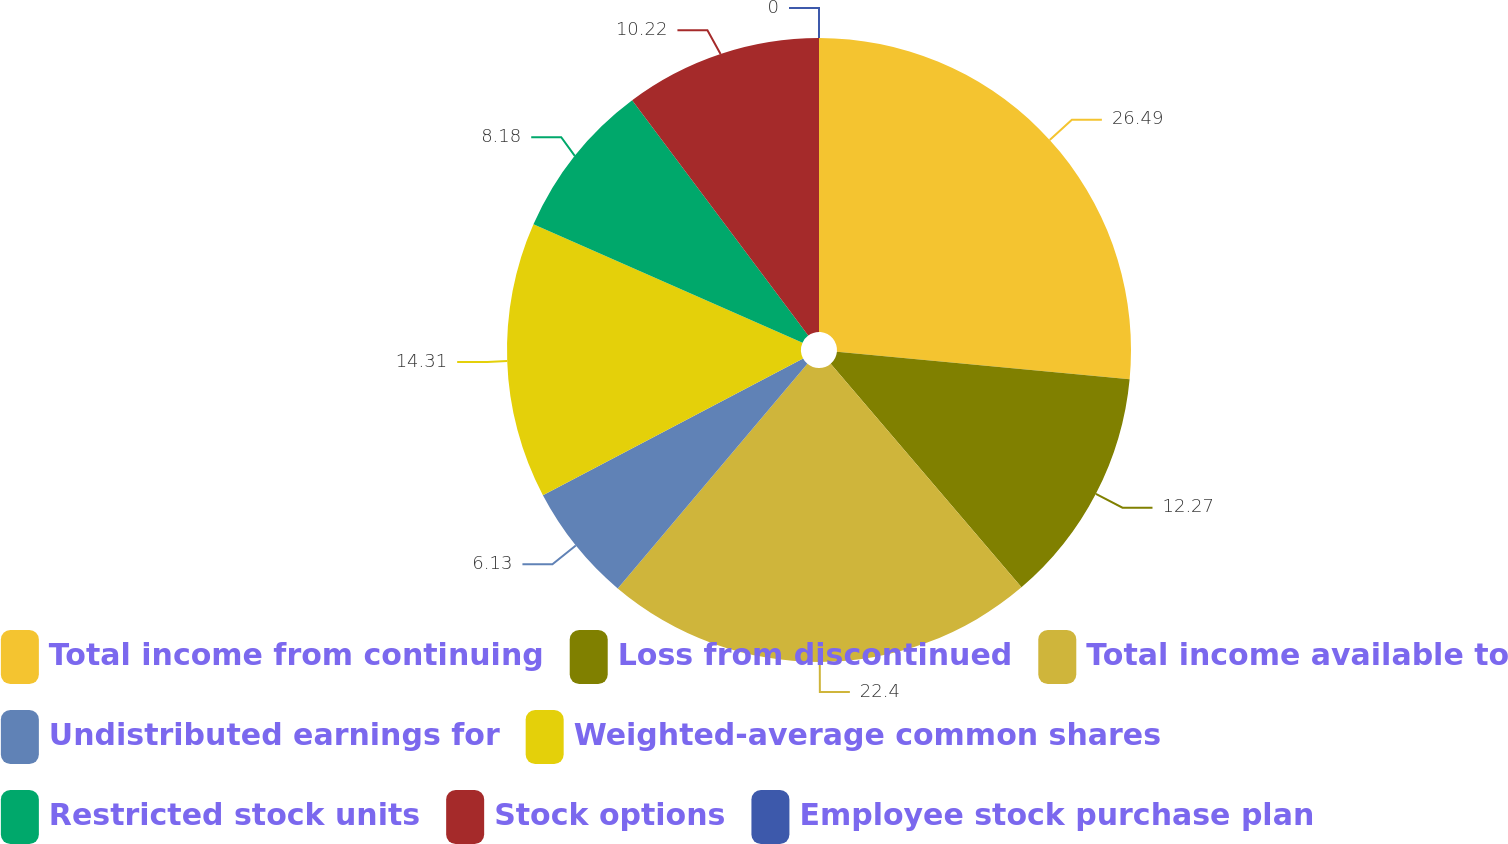<chart> <loc_0><loc_0><loc_500><loc_500><pie_chart><fcel>Total income from continuing<fcel>Loss from discontinued<fcel>Total income available to<fcel>Undistributed earnings for<fcel>Weighted-average common shares<fcel>Restricted stock units<fcel>Stock options<fcel>Employee stock purchase plan<nl><fcel>26.49%<fcel>12.27%<fcel>22.4%<fcel>6.13%<fcel>14.31%<fcel>8.18%<fcel>10.22%<fcel>0.0%<nl></chart> 